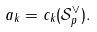<formula> <loc_0><loc_0><loc_500><loc_500>a _ { k } = c _ { k } ( { \mathcal { S } } _ { p } ^ { \vee } ) .</formula> 